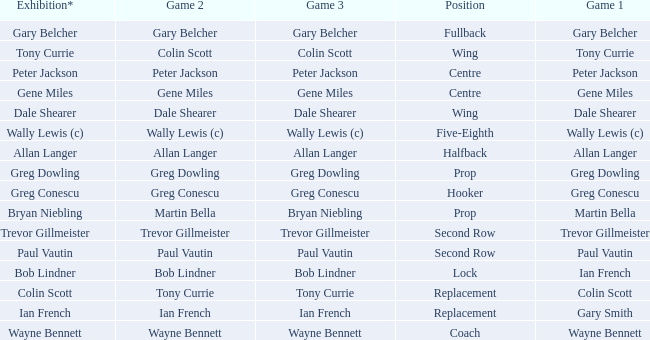What exhibition has greg conescu as game 1? Greg Conescu. 